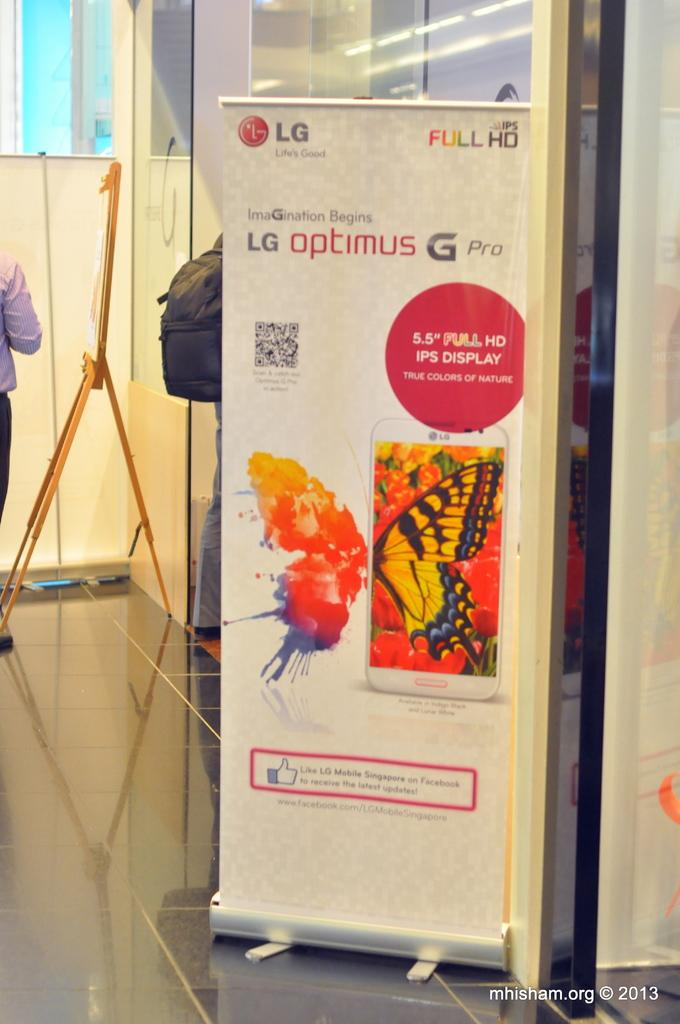<image>
Describe the image concisely. a poster inside of a building that sayas 'lg optimus g pro' on it 